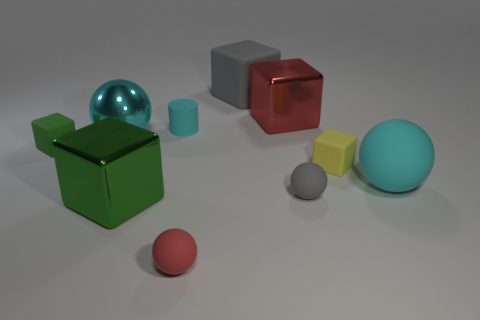Does the green matte object have the same size as the gray rubber object in front of the tiny cyan matte cylinder?
Offer a terse response. Yes. There is a cyan shiny object that is the same shape as the tiny red matte object; what size is it?
Make the answer very short. Large. There is a large metallic block to the right of the big green metal thing that is in front of the yellow cube; what number of small cyan matte things are behind it?
Provide a succinct answer. 0. How many balls are either large purple metal things or big red things?
Ensure brevity in your answer.  0. The tiny rubber cube on the left side of the metallic block that is behind the green thing that is on the right side of the cyan metal thing is what color?
Your response must be concise. Green. What number of other things are there of the same size as the red cube?
Offer a very short reply. 4. Is there any other thing that has the same shape as the large red metallic thing?
Provide a short and direct response. Yes. What is the color of the big matte thing that is the same shape as the small green thing?
Offer a very short reply. Gray. The large ball that is made of the same material as the cyan cylinder is what color?
Your response must be concise. Cyan. Are there an equal number of big red metallic things to the left of the tiny green rubber object and big metal balls?
Keep it short and to the point. No. 